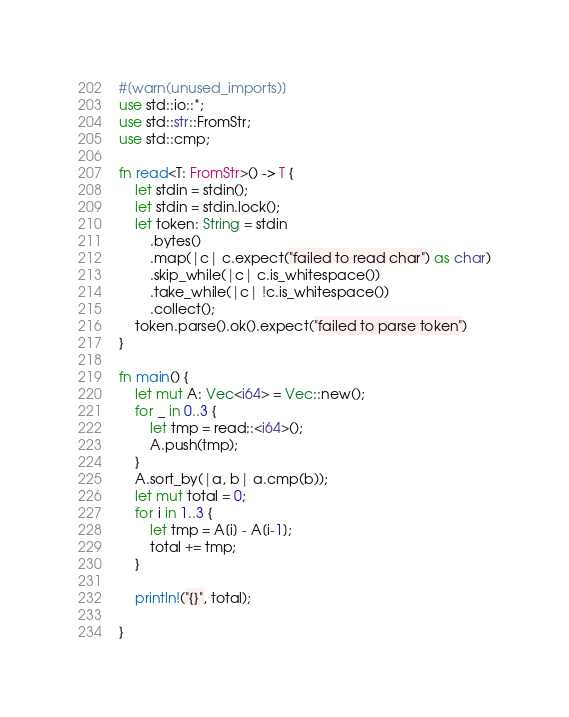Convert code to text. <code><loc_0><loc_0><loc_500><loc_500><_Rust_>#[warn(unused_imports)]
use std::io::*;
use std::str::FromStr;
use std::cmp;

fn read<T: FromStr>() -> T {
    let stdin = stdin();
    let stdin = stdin.lock();
    let token: String = stdin
        .bytes()
        .map(|c| c.expect("failed to read char") as char)
        .skip_while(|c| c.is_whitespace())
        .take_while(|c| !c.is_whitespace())
        .collect();
    token.parse().ok().expect("failed to parse token")
}

fn main() {
    let mut A: Vec<i64> = Vec::new();
    for _ in 0..3 {
        let tmp = read::<i64>();
        A.push(tmp);
    }
    A.sort_by(|a, b| a.cmp(b));
    let mut total = 0;
    for i in 1..3 {
        let tmp = A[i] - A[i-1];
        total += tmp;
    }

    println!("{}", total);

}</code> 